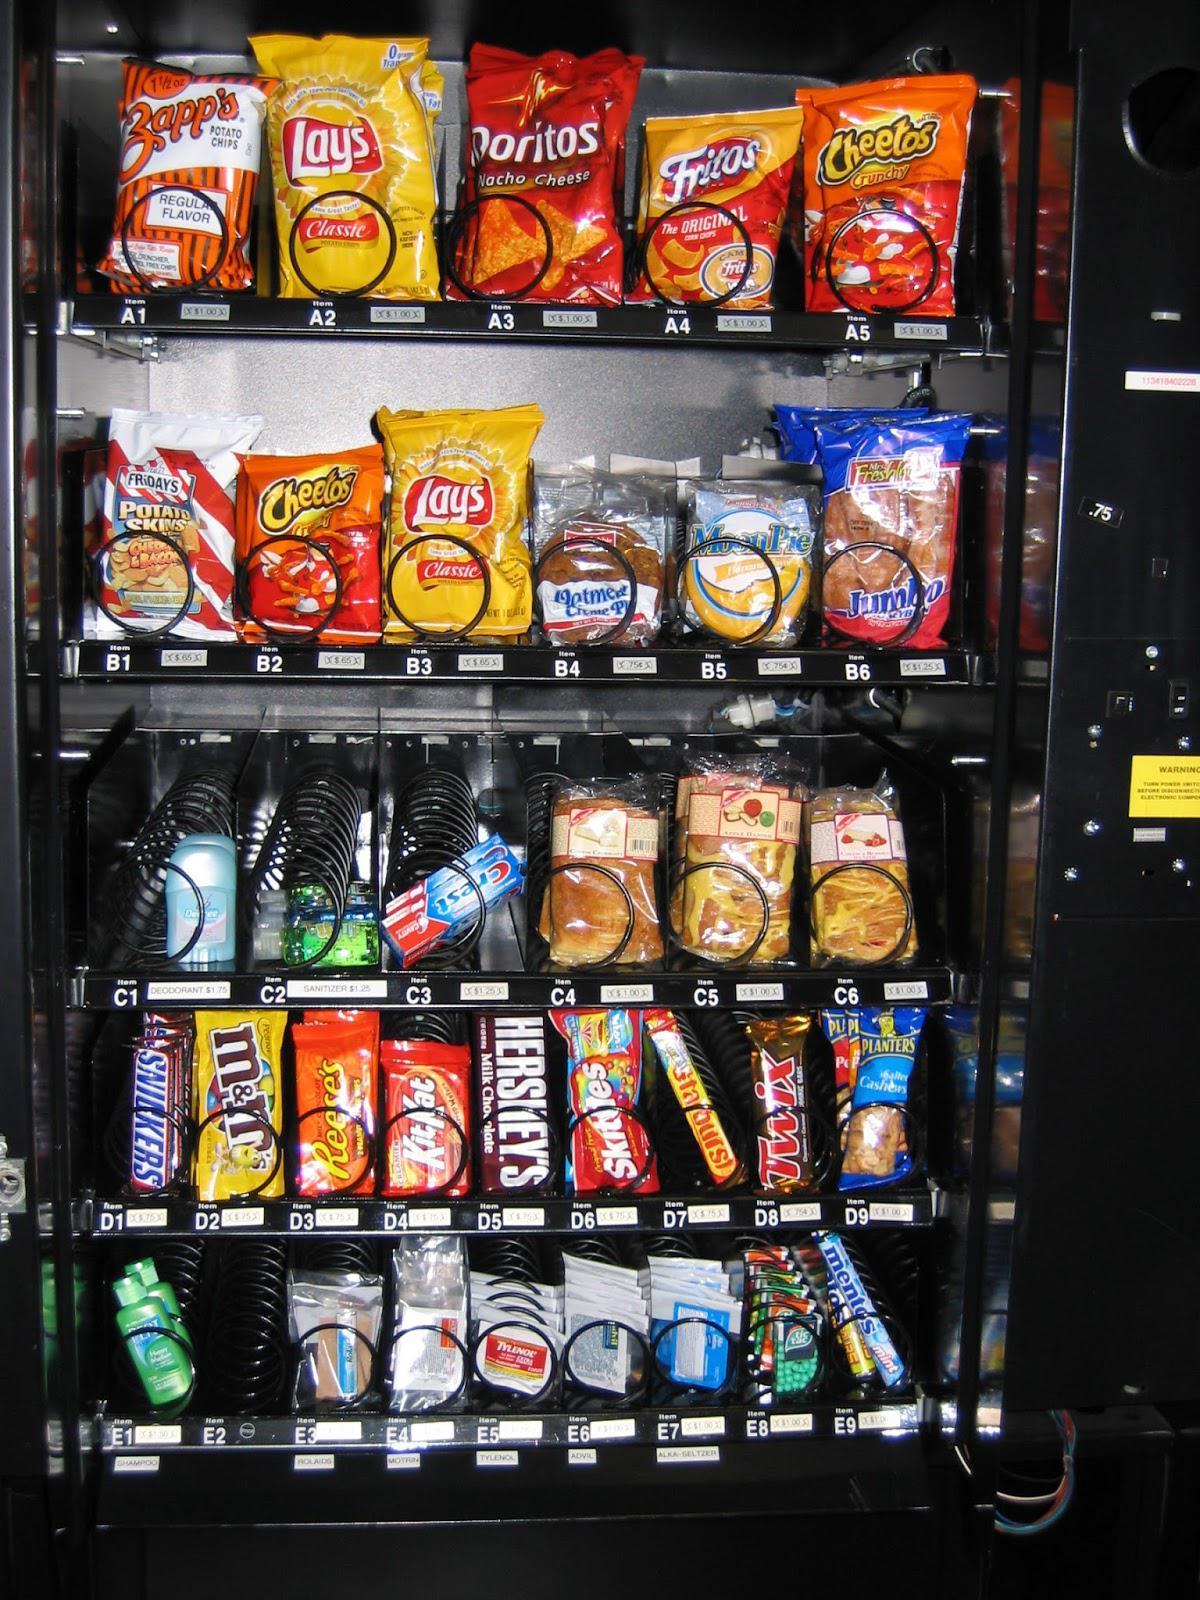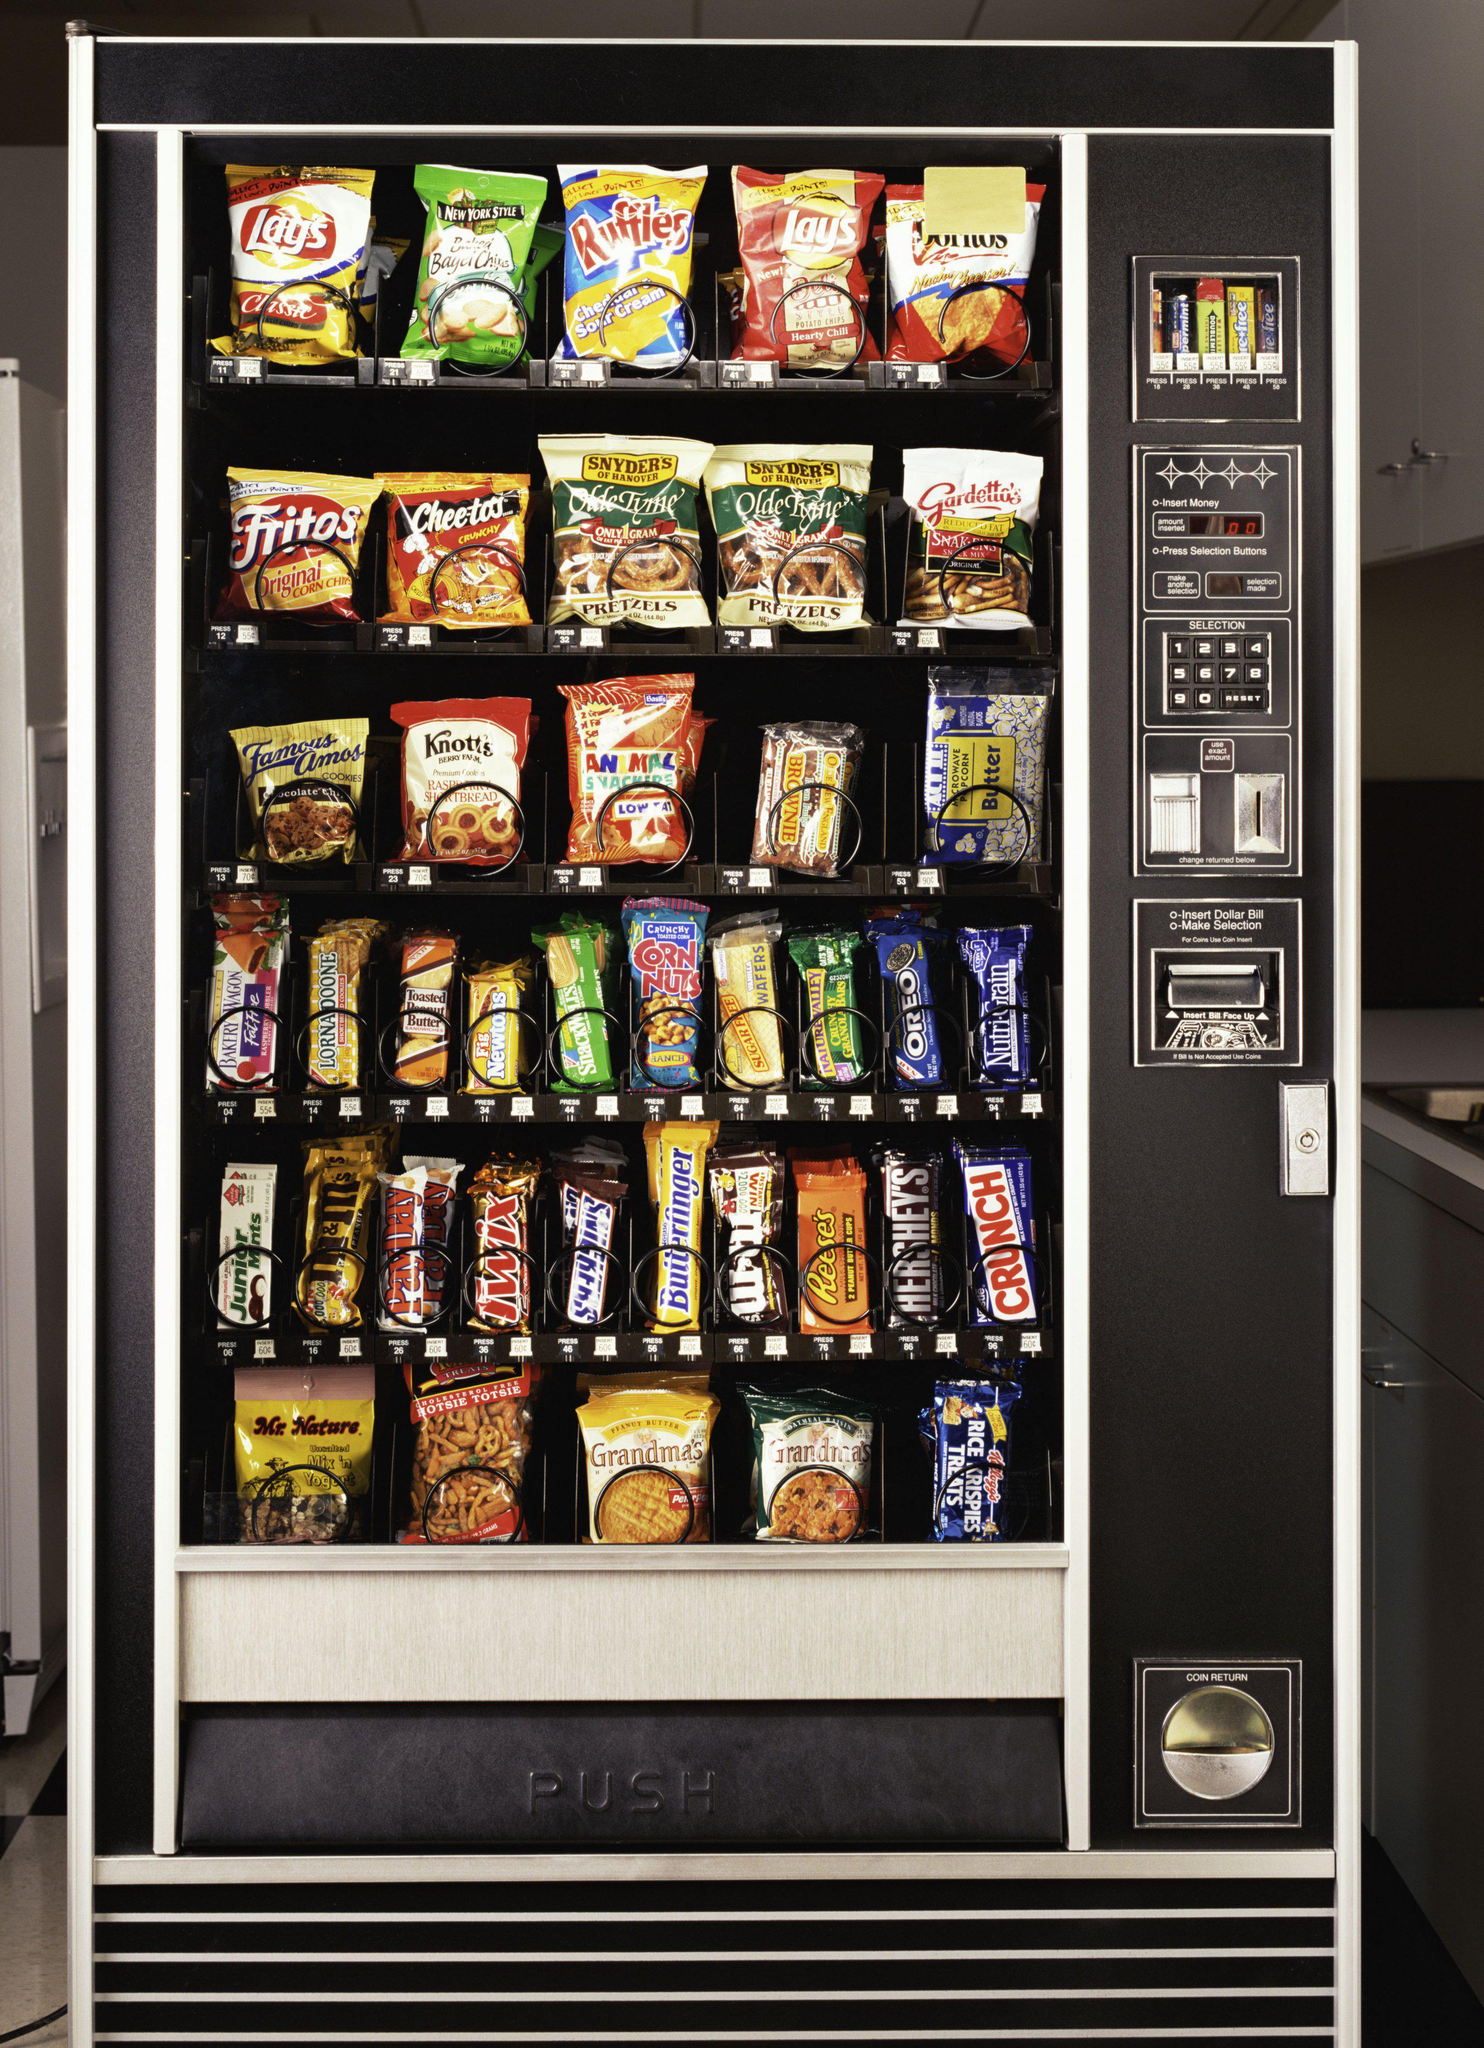The first image is the image on the left, the second image is the image on the right. Evaluate the accuracy of this statement regarding the images: "Exactly two vending machines filled with snacks are shown.". Is it true? Answer yes or no. Yes. 